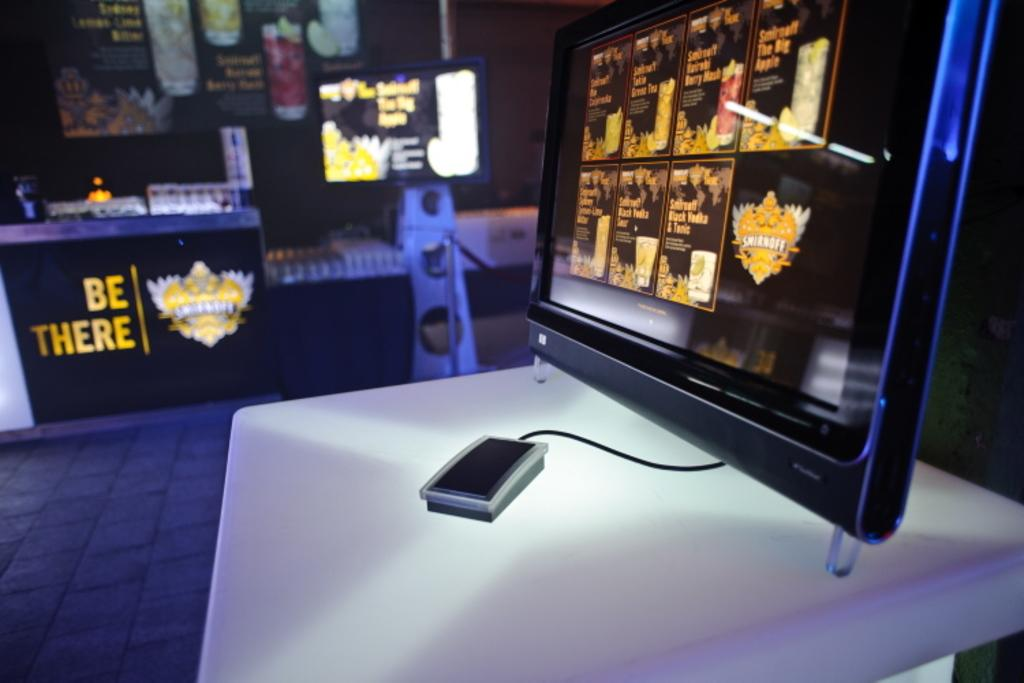Provide a one-sentence caption for the provided image. A mouse is tethered to a computer monitor which sits on a table displaying be there. 